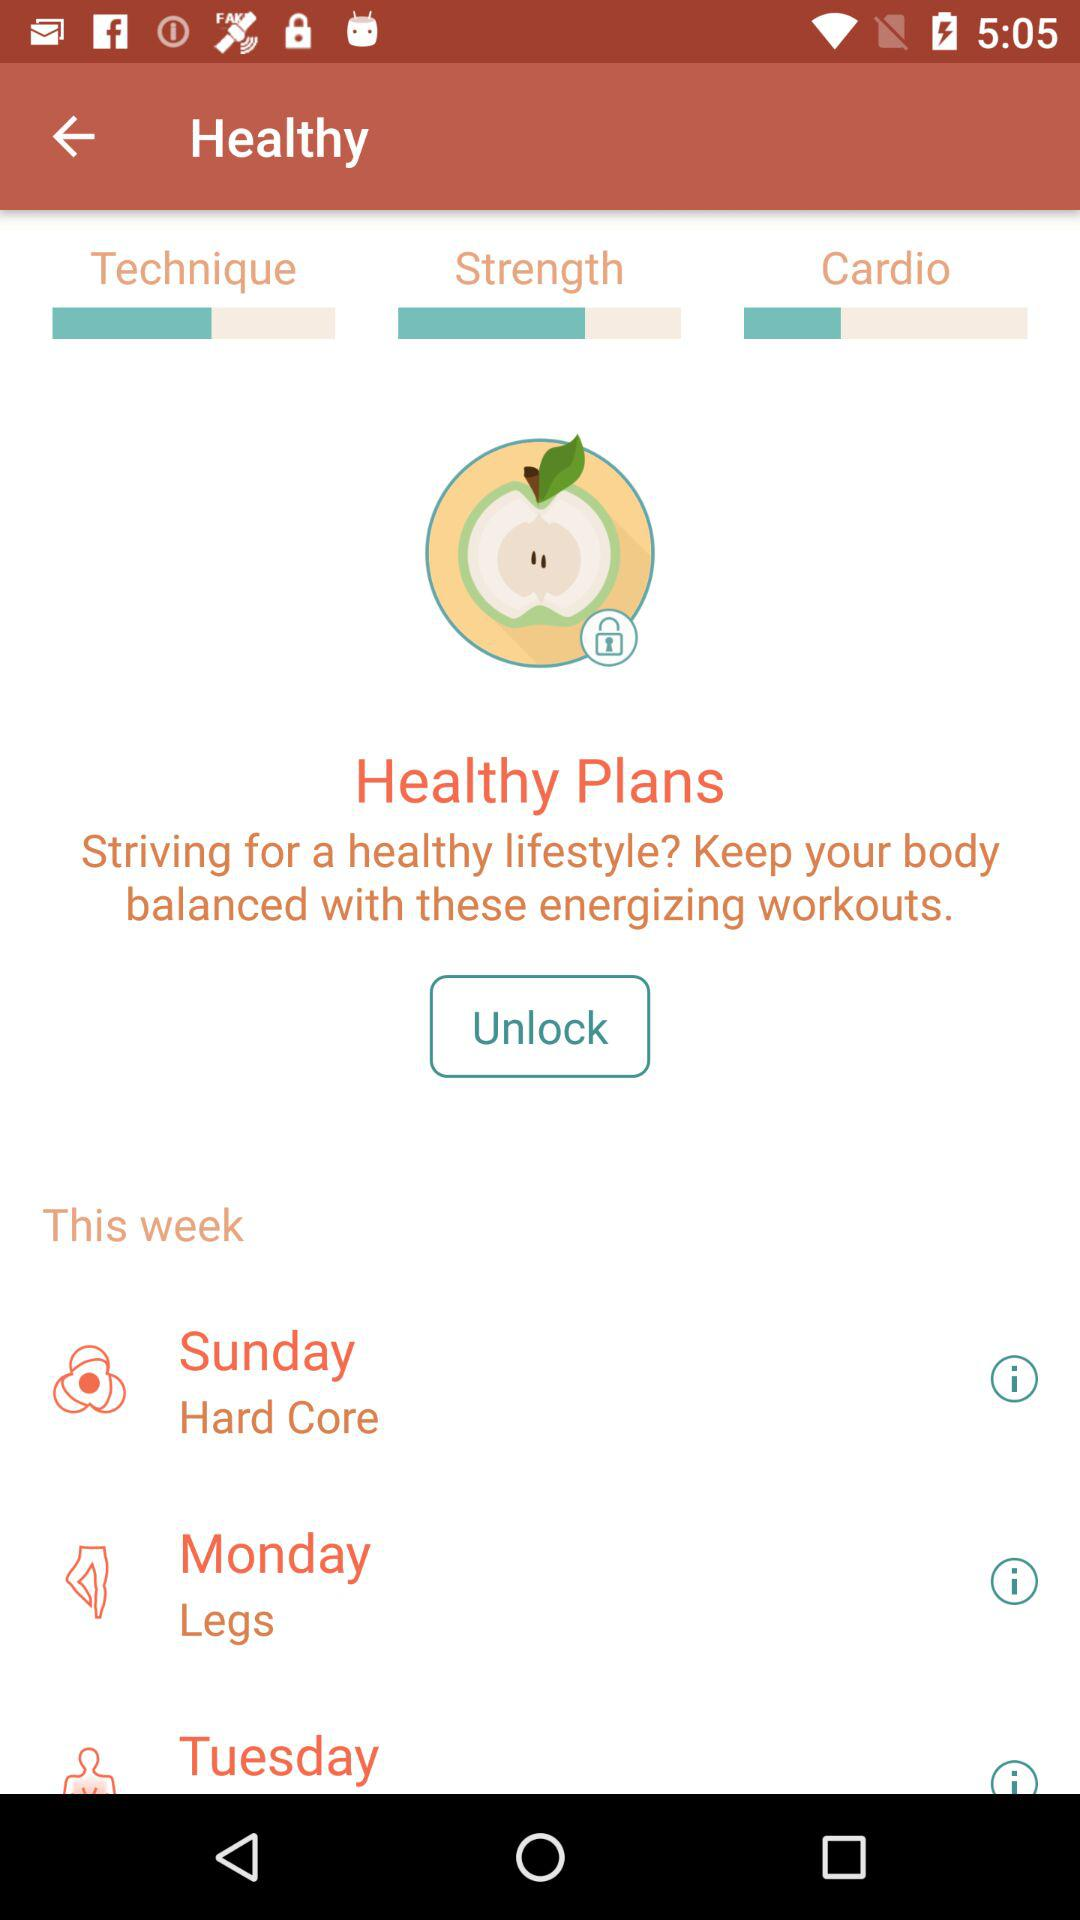What is the workout plan for Monday? The workout plan is "Legs". 